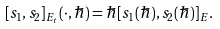<formula> <loc_0><loc_0><loc_500><loc_500>[ s _ { 1 } , s _ { 2 } ] _ { E _ { t } } ( \cdot , \hbar { ) } = \hbar { [ } s _ { 1 } ( \hbar { ) } , s _ { 2 } ( \hbar { ) } ] _ { E } .</formula> 